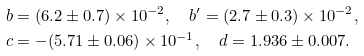Convert formula to latex. <formula><loc_0><loc_0><loc_500><loc_500>b & = ( 6 . 2 \pm 0 . 7 ) \times 1 0 ^ { - 2 } , \quad b ^ { \prime } = ( 2 . 7 \pm 0 . 3 ) \times 1 0 ^ { - 2 } , \\ c & = - ( 5 . 7 1 \pm 0 . 0 6 ) \times 1 0 ^ { - 1 } , \quad d = 1 . 9 3 6 \pm 0 . 0 0 7 .</formula> 